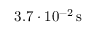Convert formula to latex. <formula><loc_0><loc_0><loc_500><loc_500>3 . 7 \cdot 1 0 ^ { - 2 } \, s</formula> 